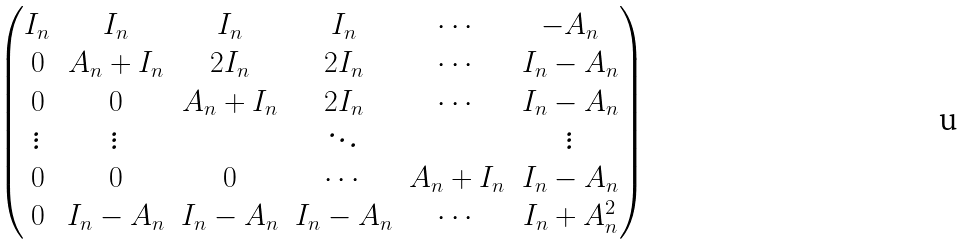Convert formula to latex. <formula><loc_0><loc_0><loc_500><loc_500>\begin{pmatrix} I _ { n } & I _ { n } & I _ { n } & I _ { n } & \cdots & - A _ { n } \\ 0 & A _ { n } + I _ { n } & 2 I _ { n } & 2 I _ { n } & \cdots & I _ { n } - A _ { n } \\ 0 & 0 & A _ { n } + I _ { n } & 2 I _ { n } & \cdots & I _ { n } - A _ { n } \\ \vdots & \vdots & & \ddots & & \vdots \\ 0 & 0 & 0 & \cdots & A _ { n } + I _ { n } & I _ { n } - A _ { n } \\ 0 & I _ { n } - A _ { n } & I _ { n } - A _ { n } & I _ { n } - A _ { n } & \cdots & I _ { n } + A _ { n } ^ { 2 } \end{pmatrix}</formula> 